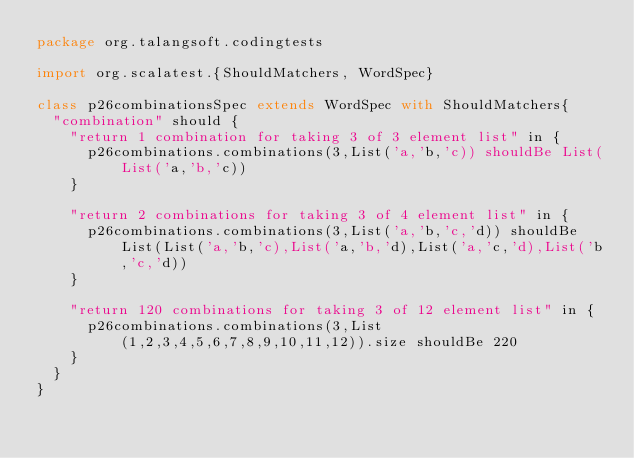<code> <loc_0><loc_0><loc_500><loc_500><_Scala_>package org.talangsoft.codingtests

import org.scalatest.{ShouldMatchers, WordSpec}

class p26combinationsSpec extends WordSpec with ShouldMatchers{
  "combination" should {
    "return 1 combination for taking 3 of 3 element list" in {
      p26combinations.combinations(3,List('a,'b,'c)) shouldBe List(List('a,'b,'c))
    }

    "return 2 combinations for taking 3 of 4 element list" in {
      p26combinations.combinations(3,List('a,'b,'c,'d)) shouldBe List(List('a,'b,'c),List('a,'b,'d),List('a,'c,'d),List('b,'c,'d))
    }

    "return 120 combinations for taking 3 of 12 element list" in {
      p26combinations.combinations(3,List(1,2,3,4,5,6,7,8,9,10,11,12)).size shouldBe 220
    }
  }
}
</code> 